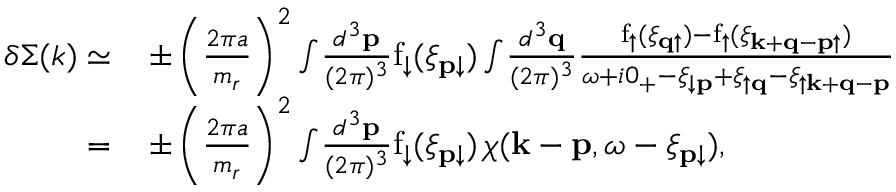<formula> <loc_0><loc_0><loc_500><loc_500>\begin{array} { r l } { \delta \Sigma ( k ) \simeq } & { \, \pm \left ( \frac { 2 \pi a } { m _ { r } } \right ) ^ { 2 } \int \, \frac { d ^ { 3 } p } { ( 2 \pi ) ^ { 3 } } f _ { \downarrow } ( \xi _ { p \downarrow } ) \int \, \frac { d ^ { 3 } q } { ( 2 \pi ) ^ { 3 } } \frac { f _ { \uparrow } ( \xi _ { q \uparrow } ) - f _ { \uparrow } ( \xi _ { k + q - p \uparrow } ) } { \omega + i 0 _ { + } - \xi _ { \downarrow p } + \xi _ { \uparrow q } - \xi _ { \uparrow k + q - p } } } \\ { = } & { \, \pm \left ( \frac { 2 \pi a } { m _ { r } } \right ) ^ { 2 } \int \, \frac { d ^ { 3 } p } { ( 2 \pi ) ^ { 3 } } f _ { \downarrow } ( \xi _ { p \downarrow } ) \, \chi ( k - p , \omega - \xi _ { p \downarrow } ) , } \end{array}</formula> 